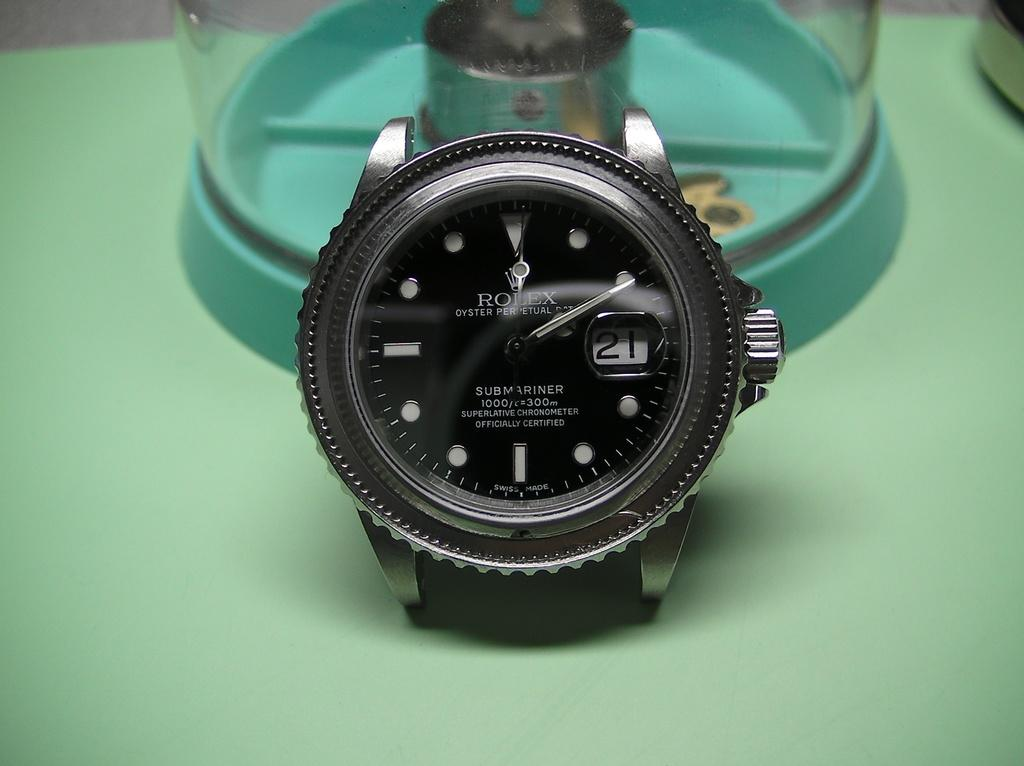<image>
Share a concise interpretation of the image provided. the Rolex is a submariner and is on display 